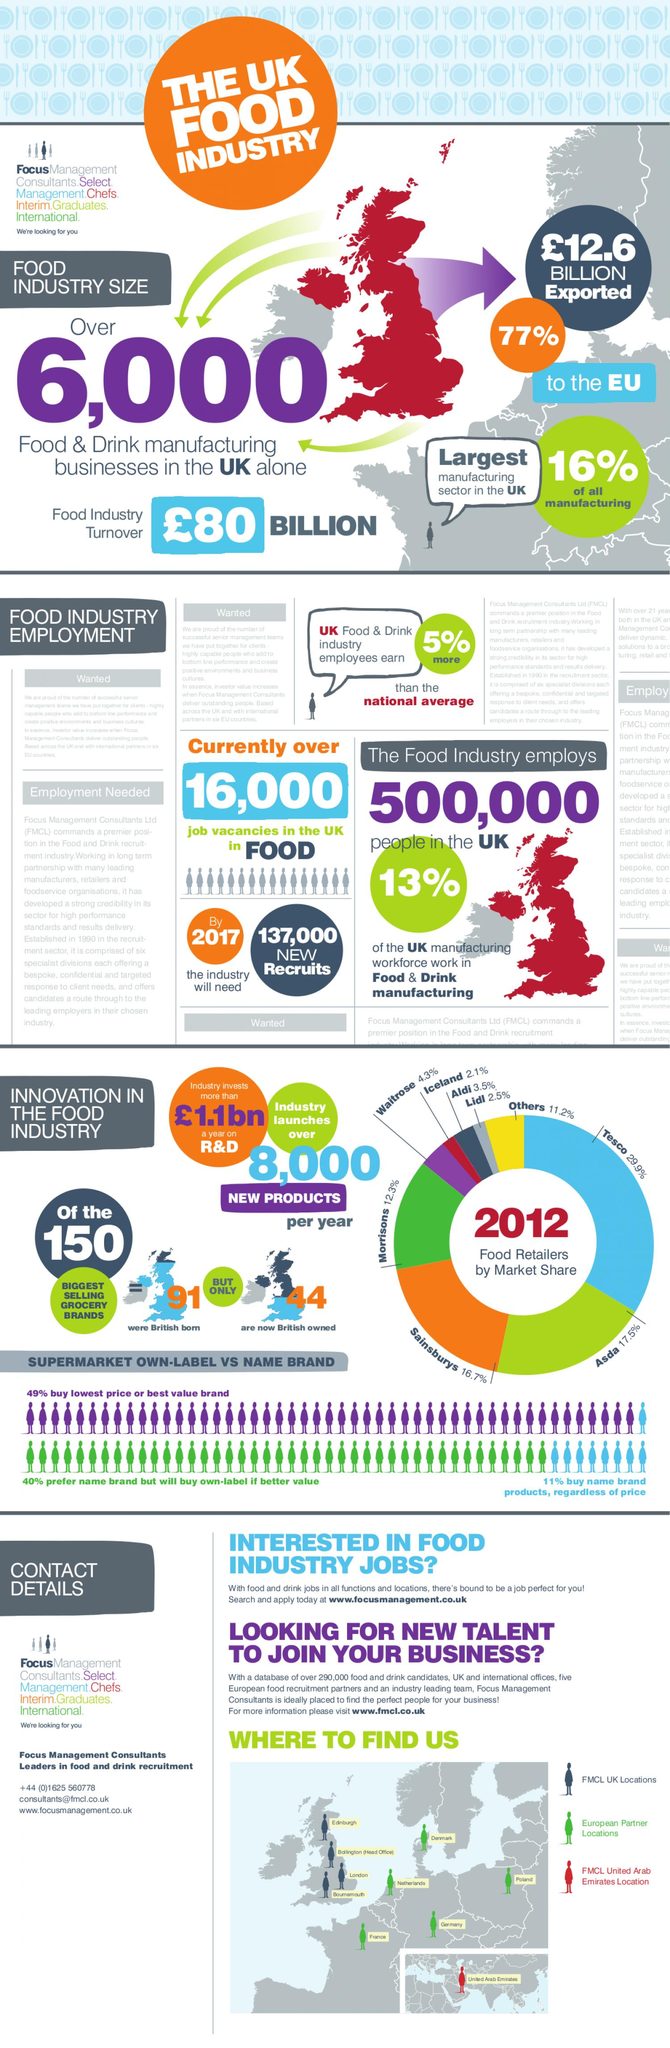Highlight a few significant elements in this photo. The food industry in the UK accounted for 77% of its total exports that were shipped to the European Union. Forty-four of the top-selling grocery brands in the world are now owned by British companies. By 2017, the Food and Drink manufacturing industry was projected to require approximately 137,000 new recruits. In the UK, the food industry is a significant contributor to the manufacturing sector, accounting for 16% of the total manufacturing output. In 2012, Asda was the second largest food retailer in the United Kingdom in terms of market share. 